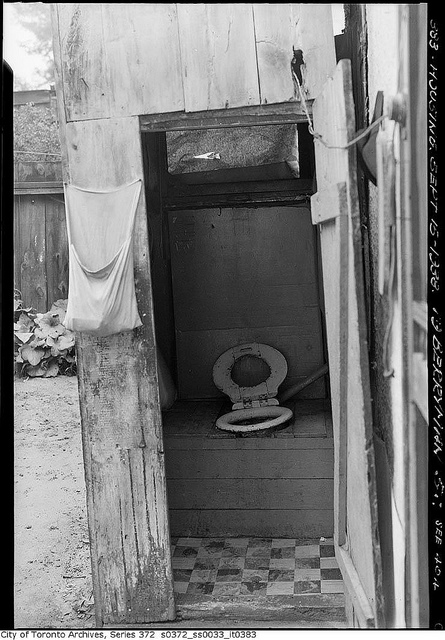<image>Why is the door open? It is unknown why the door is open. There could be several reasons such as the room being unused or empty. Why is the door open? It is unknown why the door is open. There could be several reasons such as no one in there or smell. 